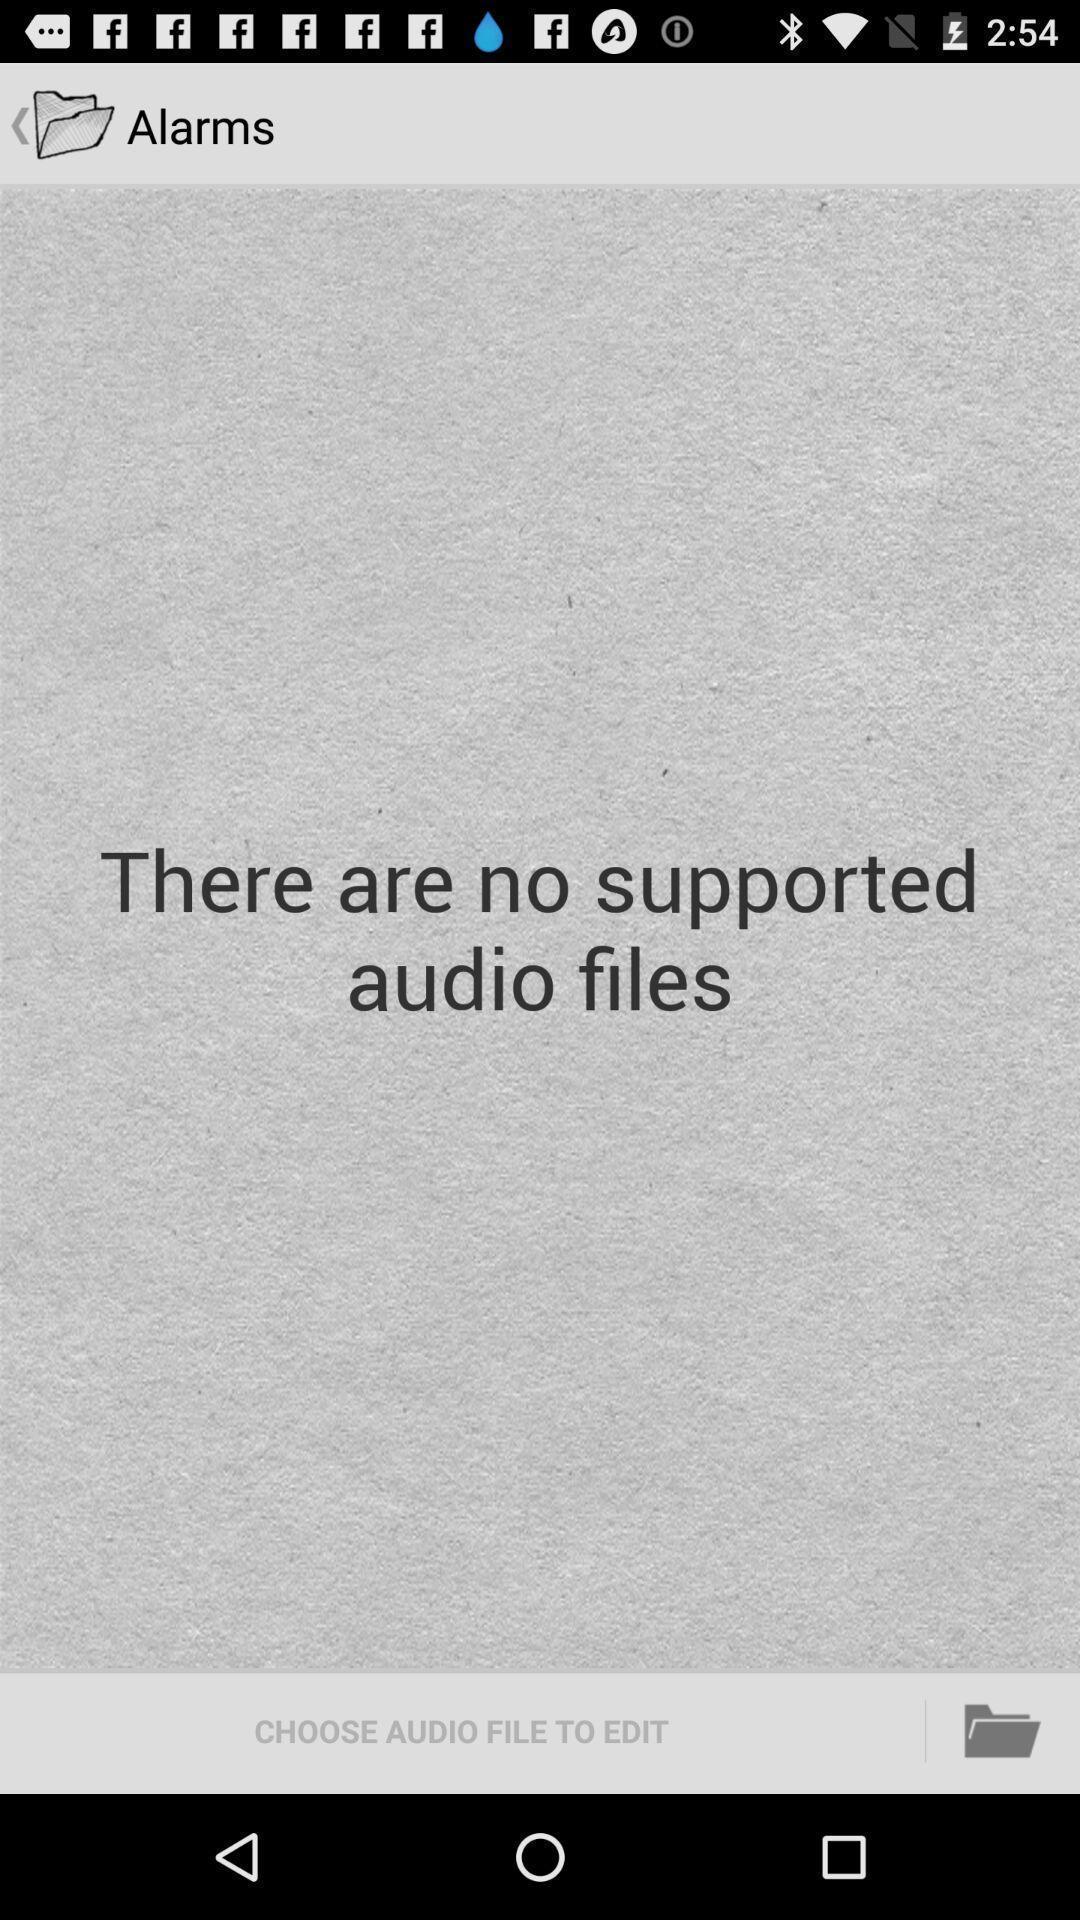Describe the visual elements of this screenshot. Screen display alarms page. 